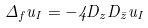<formula> <loc_0><loc_0><loc_500><loc_500>\Delta _ { f } u _ { I } = - 4 D _ { z } D _ { \bar { z } } u _ { I }</formula> 